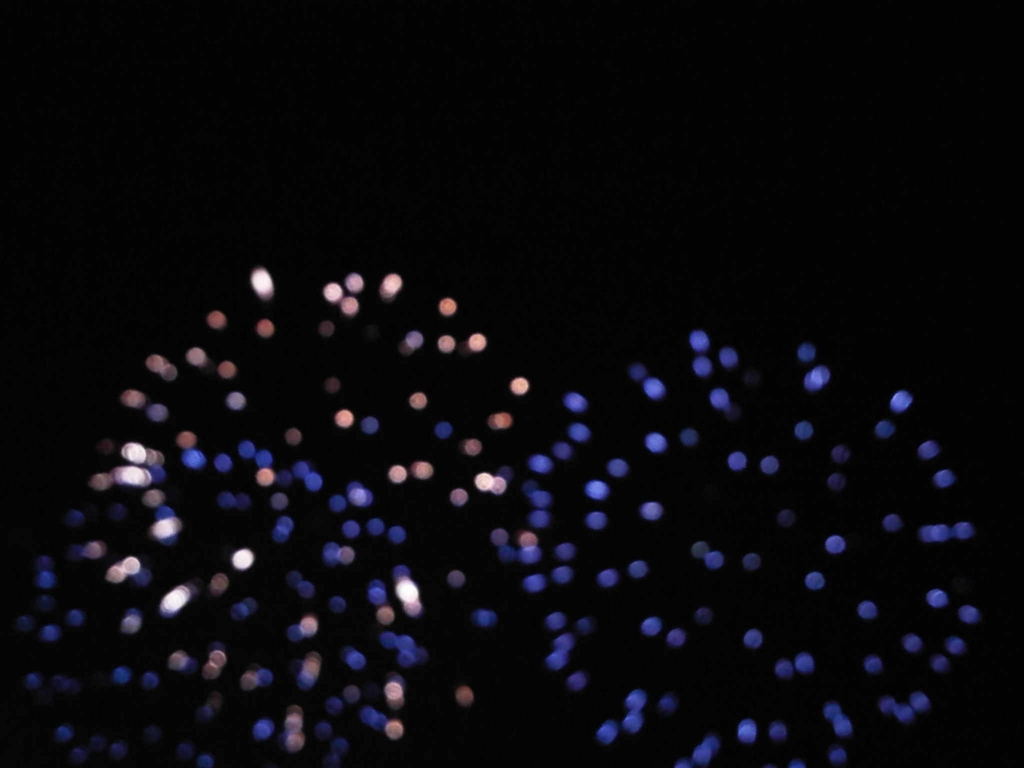What is the overall quality of this image?
A. Poor
B. Excellent
C. Average
D. Good The overall quality of the image could be considered as 'Poor' due to the lack of sharpness and abundance of blur, which makes it difficult to discern any specific details or subjects within the photograph. 